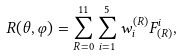<formula> <loc_0><loc_0><loc_500><loc_500>R ( \theta , \varphi ) = \sum _ { R = 0 } ^ { 1 1 } \sum _ { i = 1 } ^ { 5 } w _ { i } ^ { ( R ) } F ^ { i } _ { ( R ) } ,</formula> 